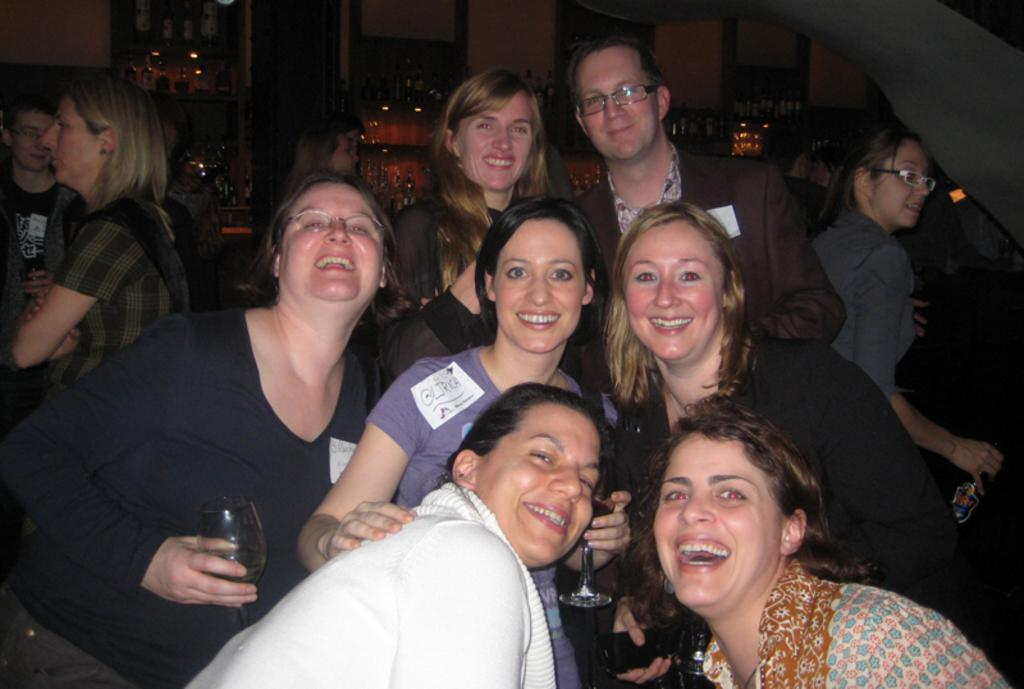What are the people in the image wearing? The persons in the image are wearing clothes. What are the persons holding in their hands? Two persons are holding glasses in their hands. What can be seen at the top of the image? There is a wall at the top of the image. Where is the toothbrush located in the image? There is no toothbrush present in the image. What is the cause of death for the person in the image? There is no person depicted as having died in the image. 